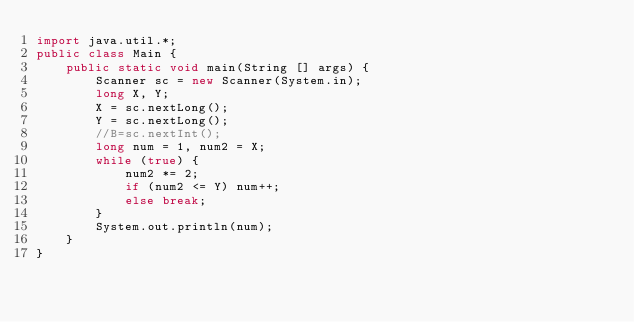<code> <loc_0><loc_0><loc_500><loc_500><_Java_>import java.util.*;
public class Main {
    public static void main(String [] args) {
        Scanner sc = new Scanner(System.in);
        long X, Y;
        X = sc.nextLong();
        Y = sc.nextLong();
        //B=sc.nextInt();
        long num = 1, num2 = X;
        while (true) {
            num2 *= 2;
            if (num2 <= Y) num++;
            else break;
        }
        System.out.println(num);
    }
}</code> 